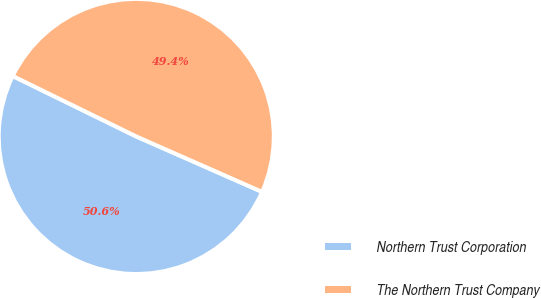<chart> <loc_0><loc_0><loc_500><loc_500><pie_chart><fcel>Northern Trust Corporation<fcel>The Northern Trust Company<nl><fcel>50.64%<fcel>49.36%<nl></chart> 